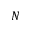Convert formula to latex. <formula><loc_0><loc_0><loc_500><loc_500>N</formula> 